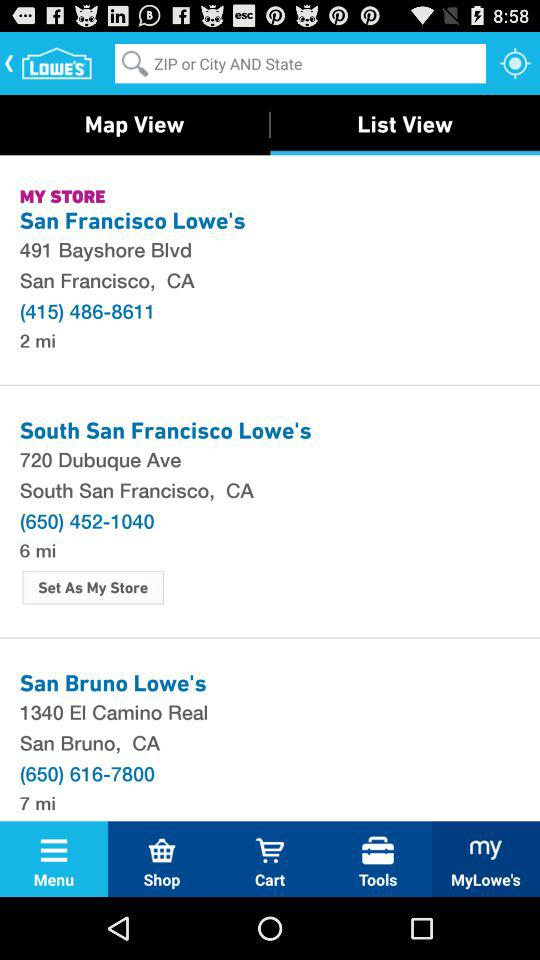Which tab is currently selected for view? The selected tab is "List View". 